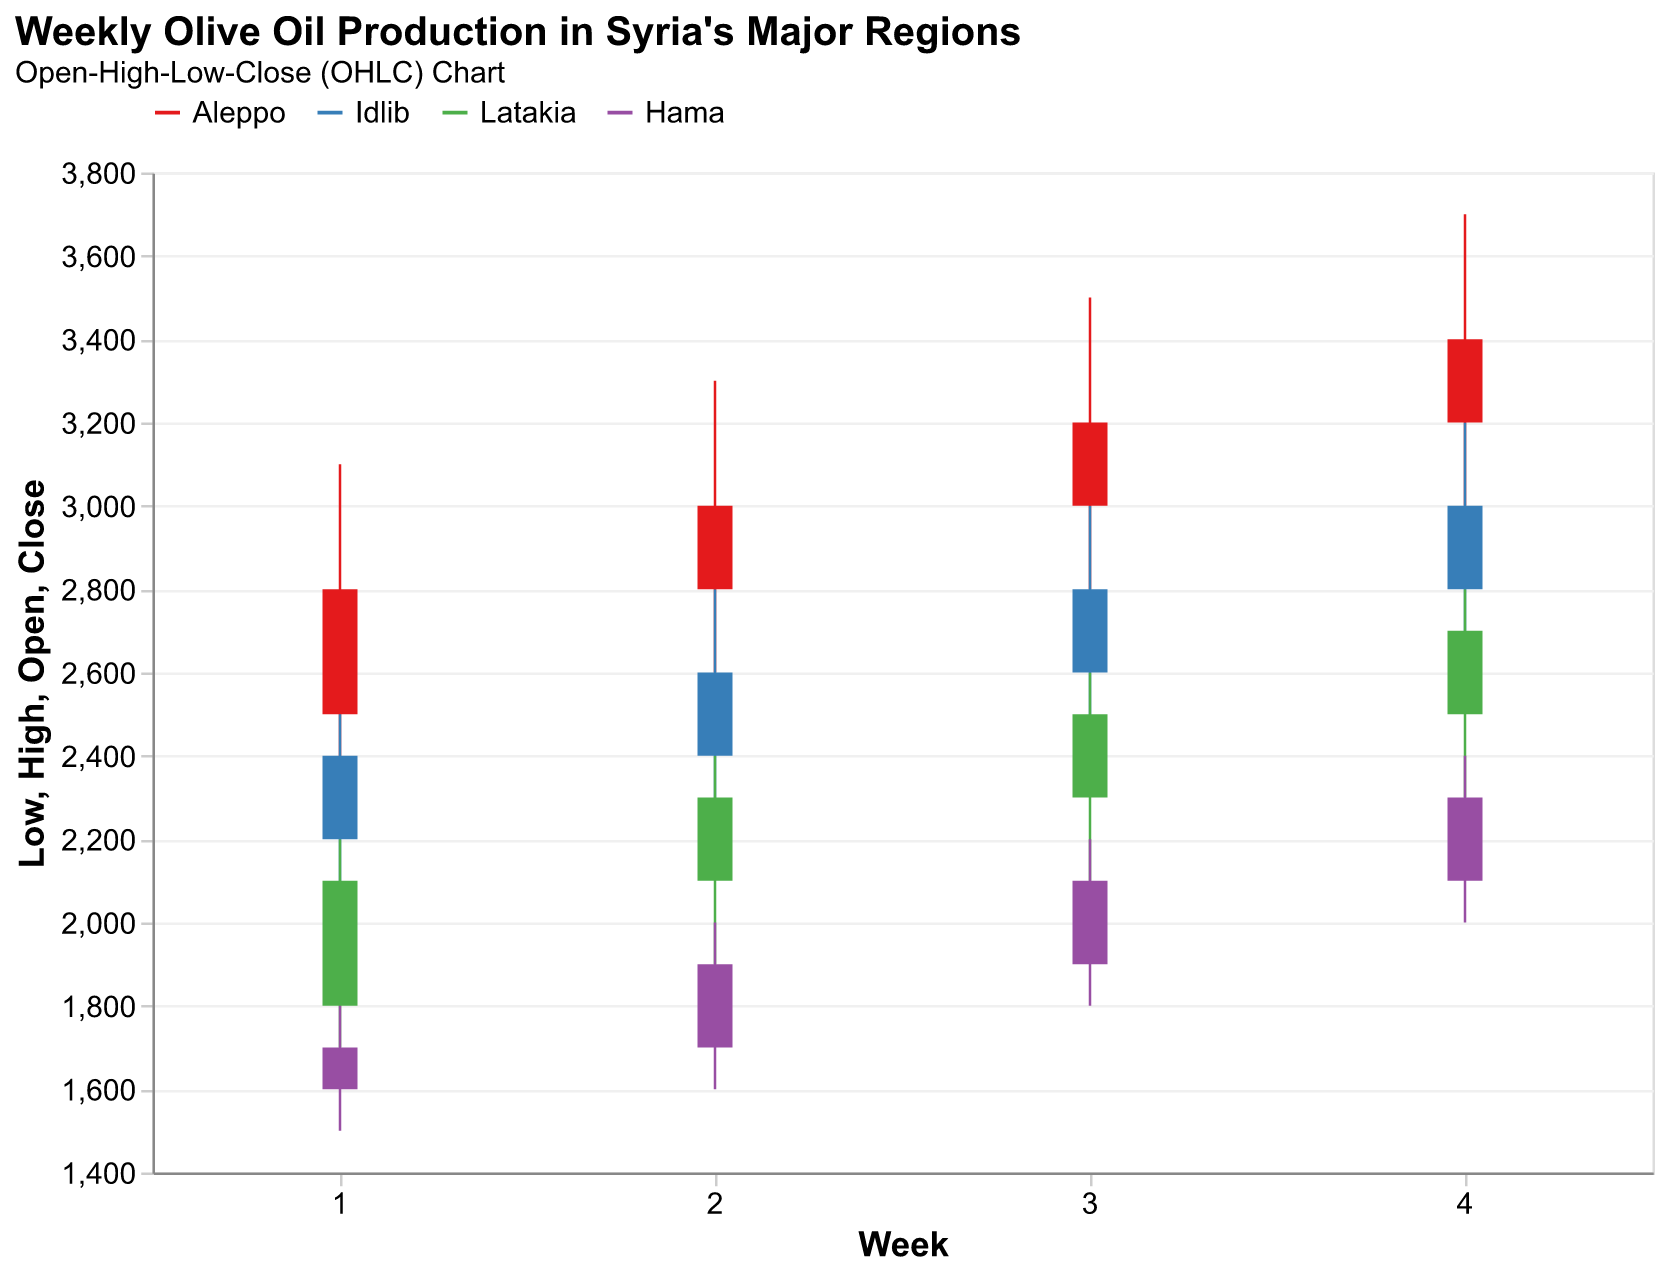What is the highest production achieved in Aleppo over the four weeks? From the chart, we can see that Aleppo's highest production is shown by the highest peak in the bar chart. In week 4, the highest production reached 3700 units.
Answer: 3700 In which week did Hama have the lowest production? The chart depicts Hama's weekly figures, and the lowest production occurred in week 1 where the lowest point is 1500 units.
Answer: Week 1 Compare the closing production in week 2 for Aleppo and Idlib. Which region had a higher closing volume? To find out, we need to look at week 2's closing values for both regions. Aleppo's closing volume is 3000, whereas Idlib's is 2600. Aleppo had a higher closing volume.
Answer: Aleppo Which week had the smallest difference between the highest and lowest production for Latakia? We calculate the difference between the highest and lowest production for each week for Latakia. Week 1: 2200-1700 = 500, Week 2: 2400-1900 = 500, Week 3: 2600-2100 = 500, Week 4: 2800-2300 = 500. All weeks have the same difference of 500 units.
Answer: All weeks What is the average closing production of Idlib over the four weeks? First, sum up the closing values for Idlib (2400 + 2600 + 2800 + 3000 = 10800). Divide by the number of weeks, which is 4. The average is 10800 / 4 = 2700.
Answer: 2700 Which region shows a consistent increase in closing production over the four weeks? By examining the closing values for every region each week, we see Aleppo's values consistently increase: 2800, 3000, 3200, 3400. Therefore, Aleppo shows a consistent increase.
Answer: Aleppo In which week did Latakia's closing production exceed Hama's closing production by the largest margin? Calculate the difference between Latakia's and Hama's closing production for each week: Week 1: 2100 - 1700 = 400, Week 2: 2300 - 1900 = 400, Week 3: 2500 - 2100 = 400, Week 4: 2700 - 2300 = 400. The difference is the same (400 units) for all weeks.
Answer: All weeks Did any region have a week where the opening production volume was higher than the previous week's closing volume? Check all regions' closing volumes of the previous week with the next week's opening volume. Aleppo: Week 1 close 2800, Week 2 open 2800. Idlib: Week 1 close 2400, Week 2 open 2400. Latakia: Week 1 close 2100, Week 2 open 2100. Hama: Week 1 close 1700, Week 2 open 1700. No region had an opening volume higher than the previous week’s closing volume.
Answer: No Which region had the highest closing production volume in week 3? Refer to week 3's closing values for all regions: Aleppo 3200, Idlib 2800, Latakia 2500, Hama 2100. Aleppo has the highest closing production volume in week 3.
Answer: Aleppo 